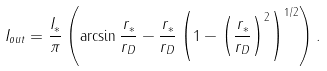<formula> <loc_0><loc_0><loc_500><loc_500>I _ { o u t } = \frac { I _ { \ast } } { \pi } \left ( \arcsin \frac { r _ { \ast } } { r _ { D } } - \frac { r _ { \ast } } { r _ { D } } \left ( 1 - \left ( \frac { r _ { \ast } } { r _ { D } } \right ) ^ { 2 } \right ) ^ { 1 / 2 } \right ) .</formula> 